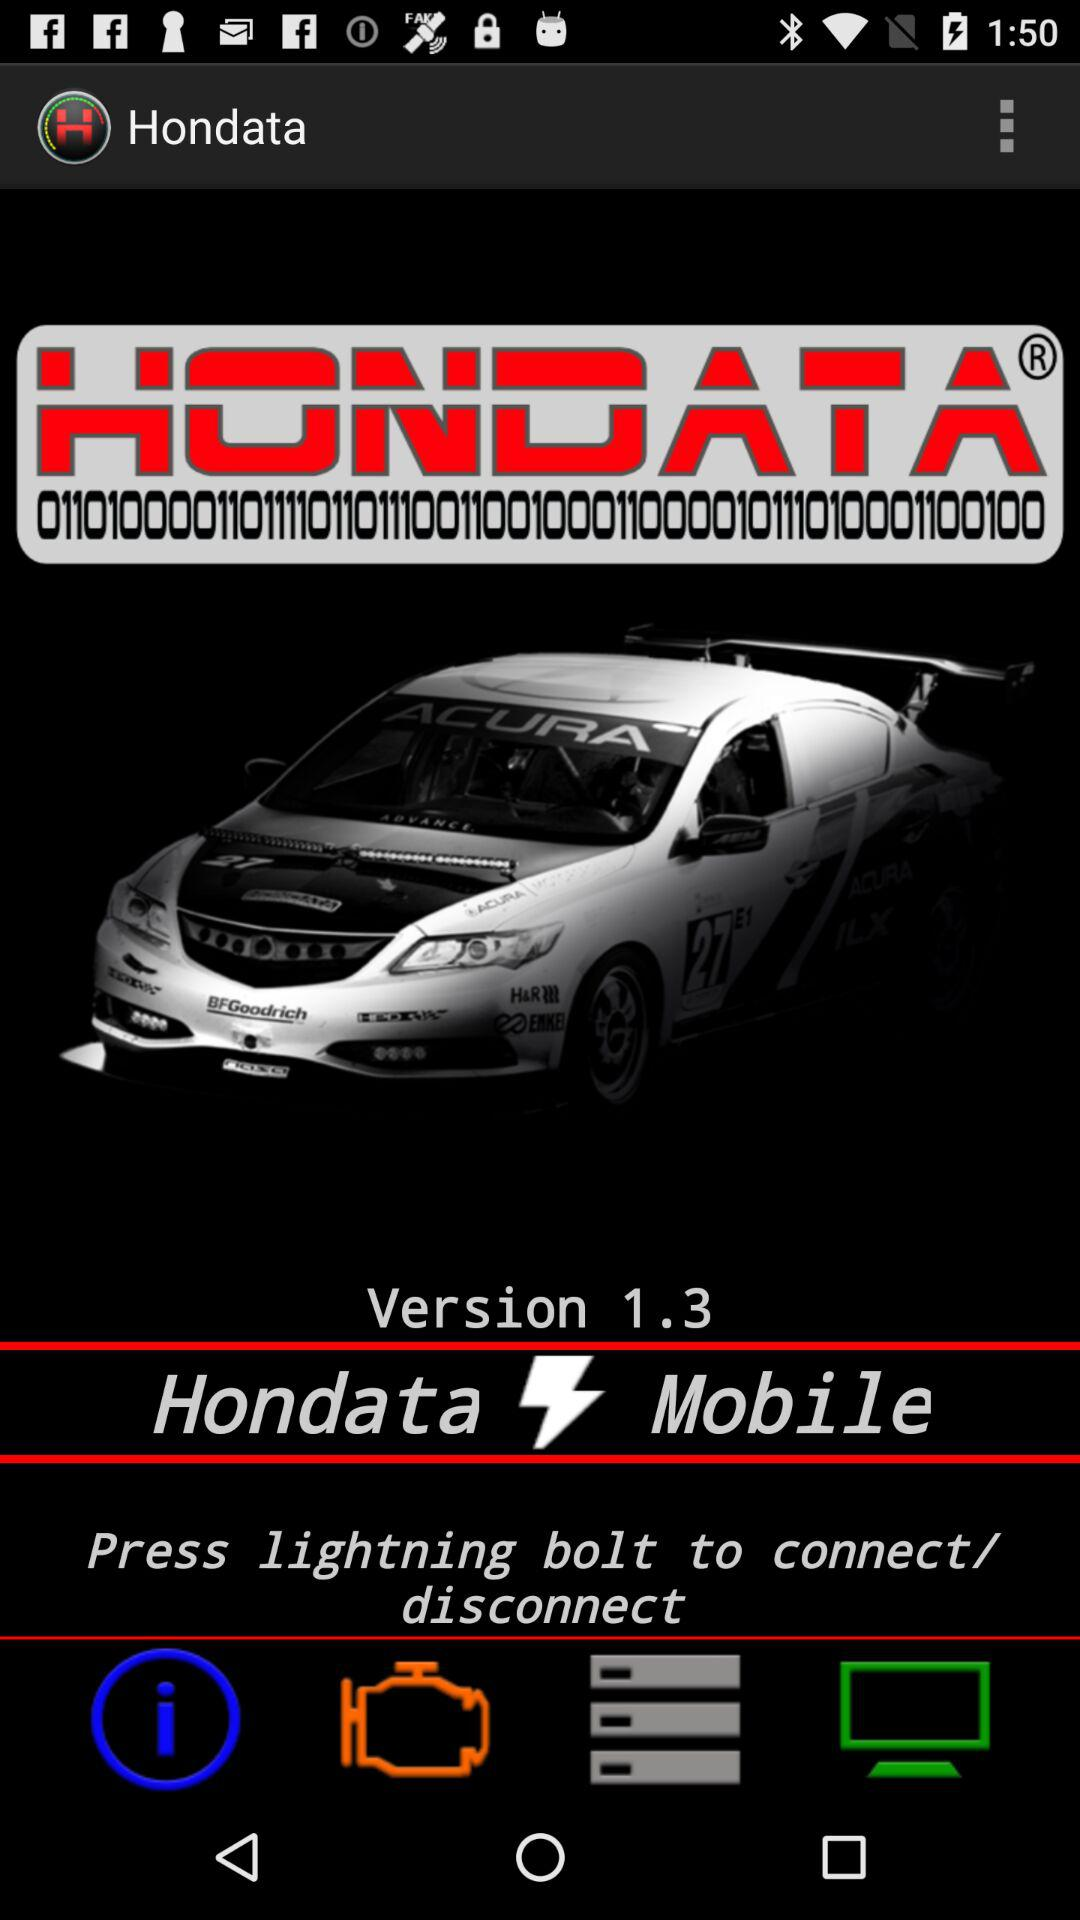What is the name of the application? The name of the application is "Hondata". 